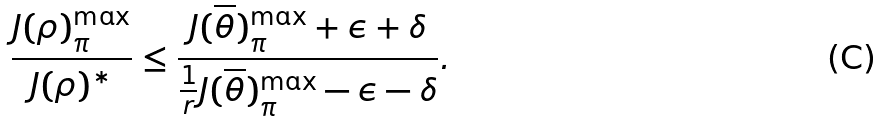<formula> <loc_0><loc_0><loc_500><loc_500>\frac { J ( \rho ) _ { \pi } ^ { \max } } { J ( \rho ) ^ { * } } \leq \frac { J ( \overline { \theta } ) _ { \pi } ^ { \max } + \epsilon + \delta } { \frac { 1 } { r } J ( \overline { \theta } ) _ { \pi } ^ { \max } - \epsilon - \delta } .</formula> 